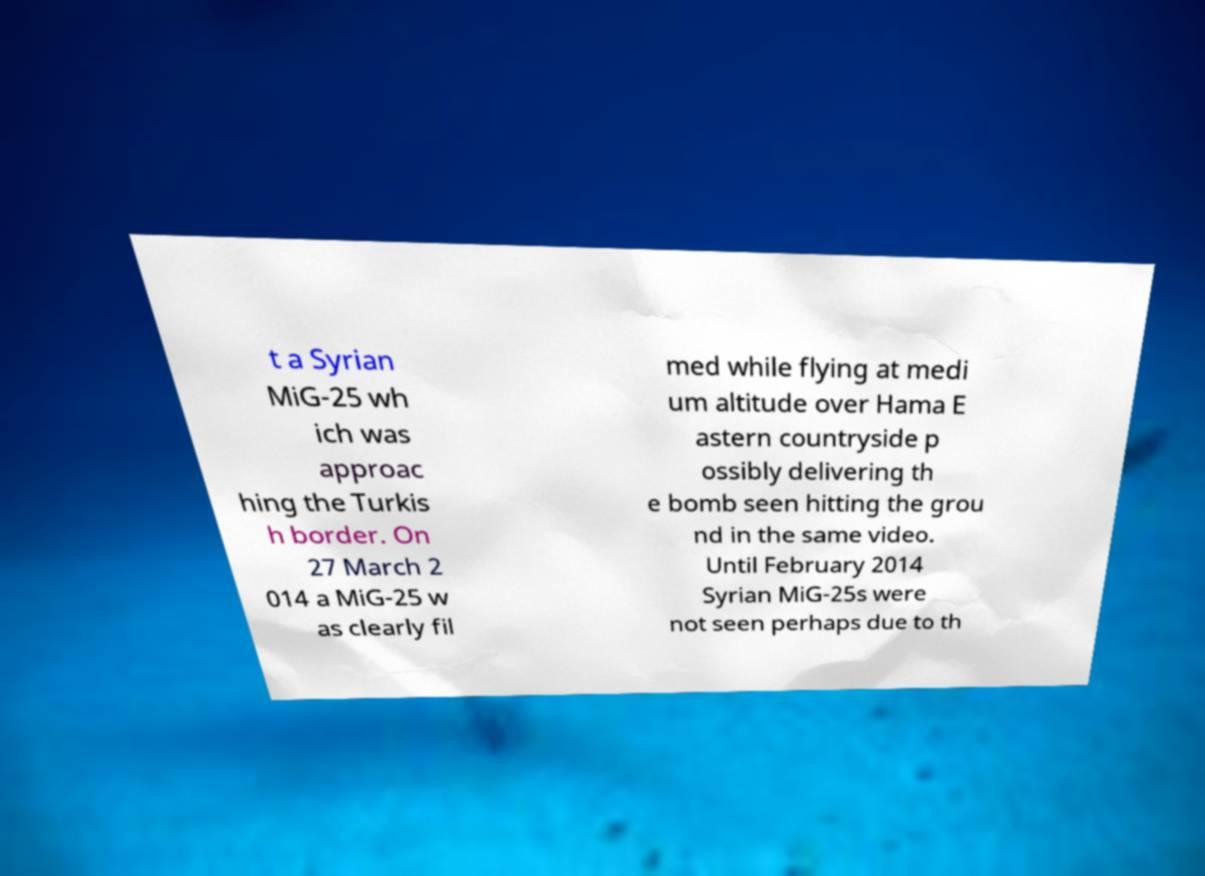Please read and relay the text visible in this image. What does it say? t a Syrian MiG-25 wh ich was approac hing the Turkis h border. On 27 March 2 014 a MiG-25 w as clearly fil med while flying at medi um altitude over Hama E astern countryside p ossibly delivering th e bomb seen hitting the grou nd in the same video. Until February 2014 Syrian MiG-25s were not seen perhaps due to th 